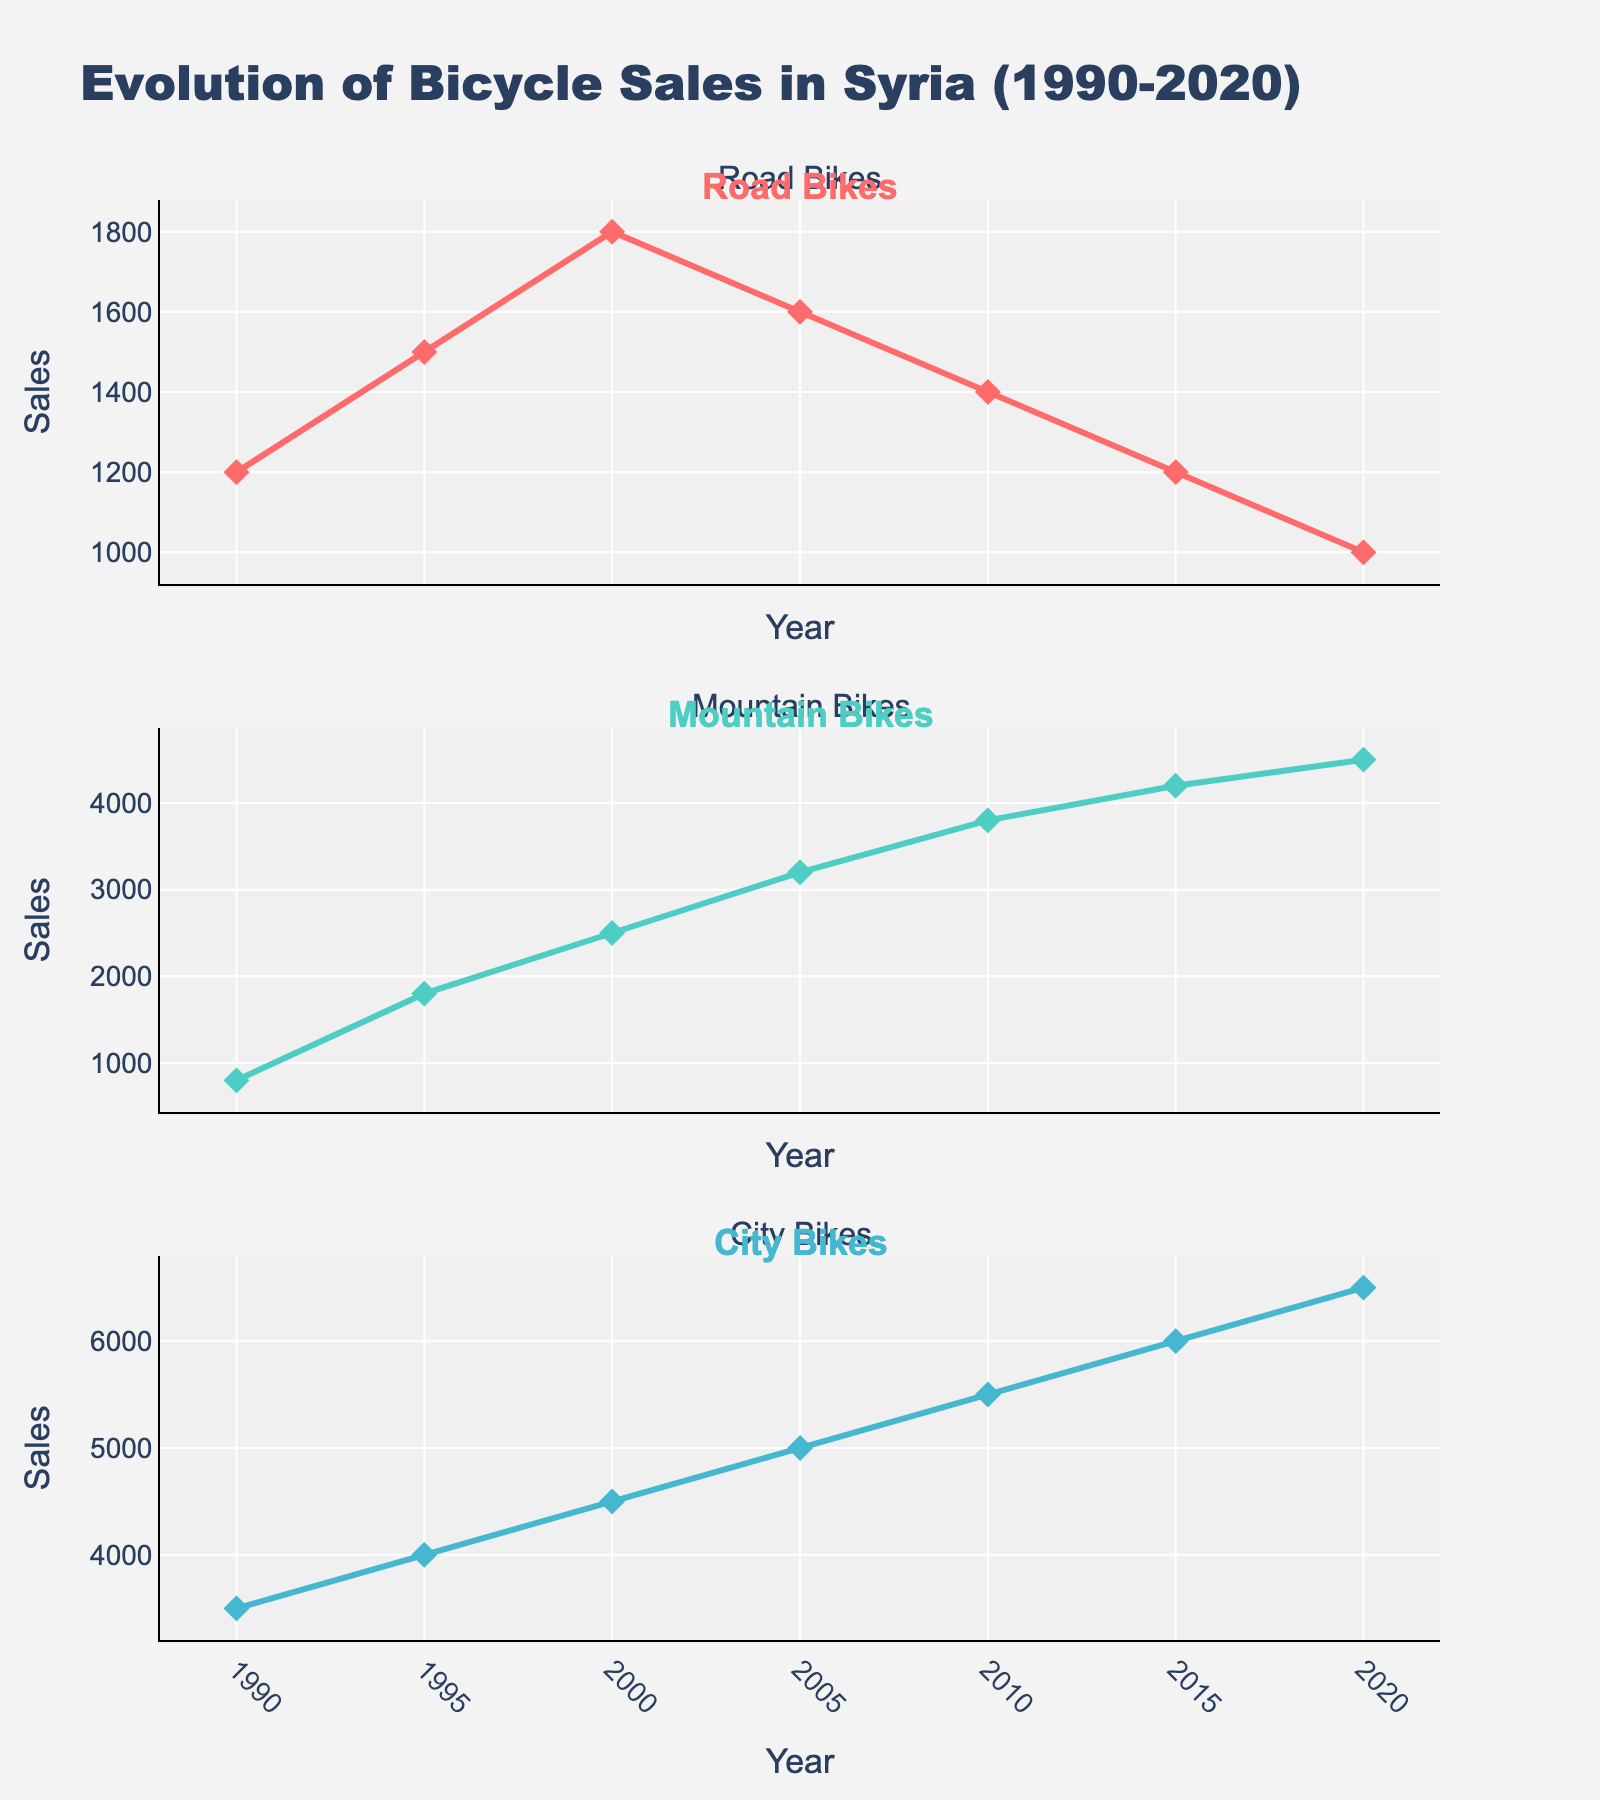Which region has the shortest average delivery time for Express shipping? Look at the bar corresponding to Express shipping and find the shortest bar. In this case, North America has the shortest average delivery time at 2 days.
Answer: North America What is the difference in average delivery time between Economy and Express shipping for Asia Pacific? Refer to the bars for Asia Pacific in both the Economy and Express subplots. The difference is calculated as 12 (Economy) - 4 (Express).
Answer: 8 days Which region has the highest average delivery time for Standard shipping? Identify the tallest bar in the Standard shipping subplot. Africa has the highest average delivery time at 10 days.
Answer: Africa Compare the average delivery times for Standard shipping between Europe and Africa. Which region is faster and by how many days? Compare the heights of the bars for Europe and Africa in the Standard shipping subplot. For Europe, it's 6 days; for Africa, it's 10 days. The difference is 10 - 6 = 4 days, with Europe being faster.
Answer: Europe, 4 days What is the average delivery time for all regions combined for Economy shipping? Sum the average delivery times for all regions in the Economy subplot and divide by the number of regions (10 in this case). Sum: 8 + 10 + 12 + 14 + 13 + 15 + 11 + 13 + 12 + 11 = 119. Average: 119/10 = 11.9.
Answer: 11.9 days How many regions have a Standard shipping average delivery time of exactly 7 days? Count the regions with a bar height of 7 days in the Standard shipping subplot. The regions are Asia Pacific, Oceania, Caribbean, and Eastern Europe, which totals to 4 regions.
Answer: 4 regions What is the total average delivery time for Economy shipping for both Europe and Middle East? Add the average delivery times for Europe and Middle East in the Economy subplot. (10 for Europe) + (13 for Middle East) = 23 days.
Answer: 23 days Which shipping method shows the least variation in average delivery times across all regions? By visually comparing the range and distribution of bar heights across Economy, Standard, and Express subplots, Express shipping has the least variation with a range of 2 to 6 days.
Answer: Express 